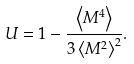Convert formula to latex. <formula><loc_0><loc_0><loc_500><loc_500>U = 1 - \frac { \left < M ^ { 4 } \right > } { 3 \left < M ^ { 2 } \right > ^ { 2 } } .</formula> 